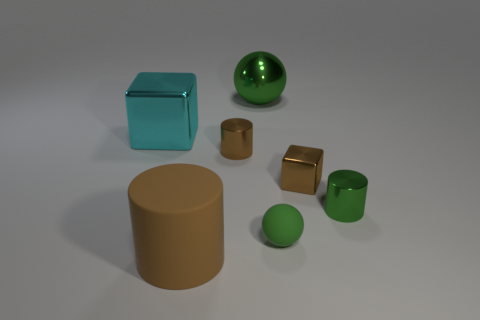Subtract all small brown metal cylinders. How many cylinders are left? 2 Subtract all blue balls. How many brown cylinders are left? 2 Add 3 tiny red metallic balls. How many objects exist? 10 Subtract all green cylinders. How many cylinders are left? 2 Subtract all spheres. How many objects are left? 5 Subtract all blue cylinders. Subtract all purple blocks. How many cylinders are left? 3 Subtract all big cyan cubes. Subtract all cylinders. How many objects are left? 3 Add 4 large metallic objects. How many large metallic objects are left? 6 Add 7 tiny shiny things. How many tiny shiny things exist? 10 Subtract 0 gray cylinders. How many objects are left? 7 